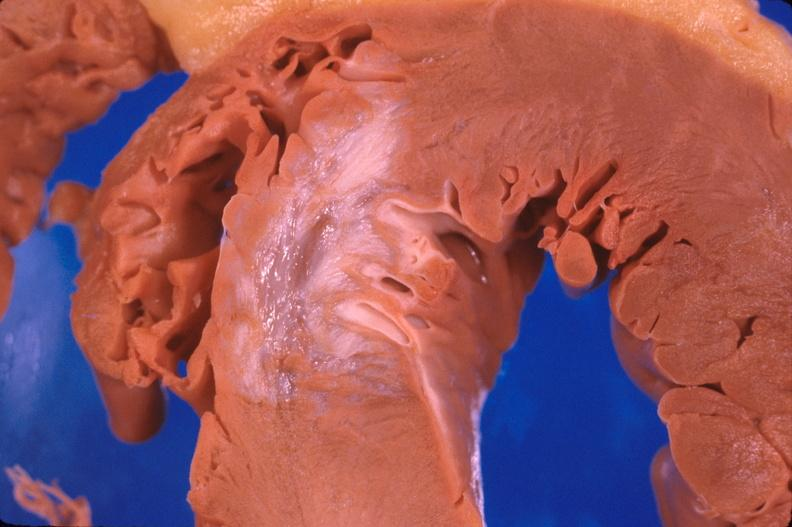what is present?
Answer the question using a single word or phrase. Cardiovascular 